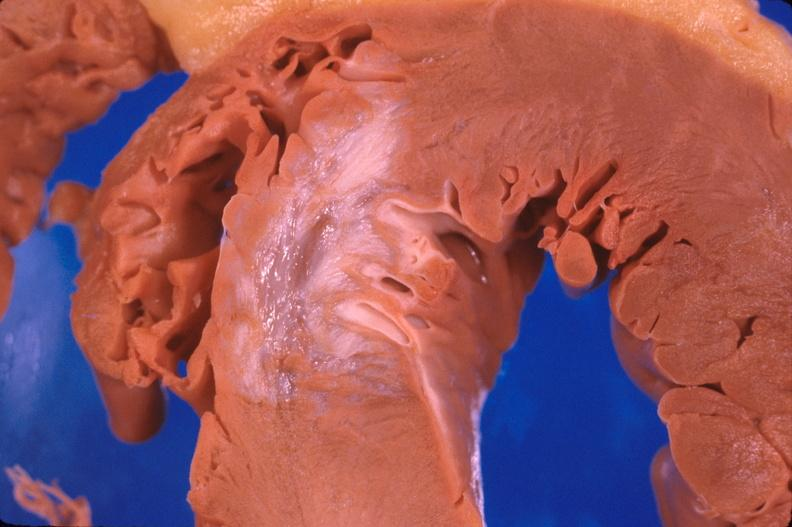what is present?
Answer the question using a single word or phrase. Cardiovascular 